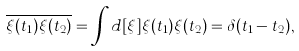Convert formula to latex. <formula><loc_0><loc_0><loc_500><loc_500>\overline { \xi ( t _ { 1 } ) \xi ( t _ { 2 } ) } = \int d [ \xi ] \xi ( t _ { 1 } ) \xi ( t _ { 2 } ) = \delta ( t _ { 1 } - t _ { 2 } ) ,</formula> 